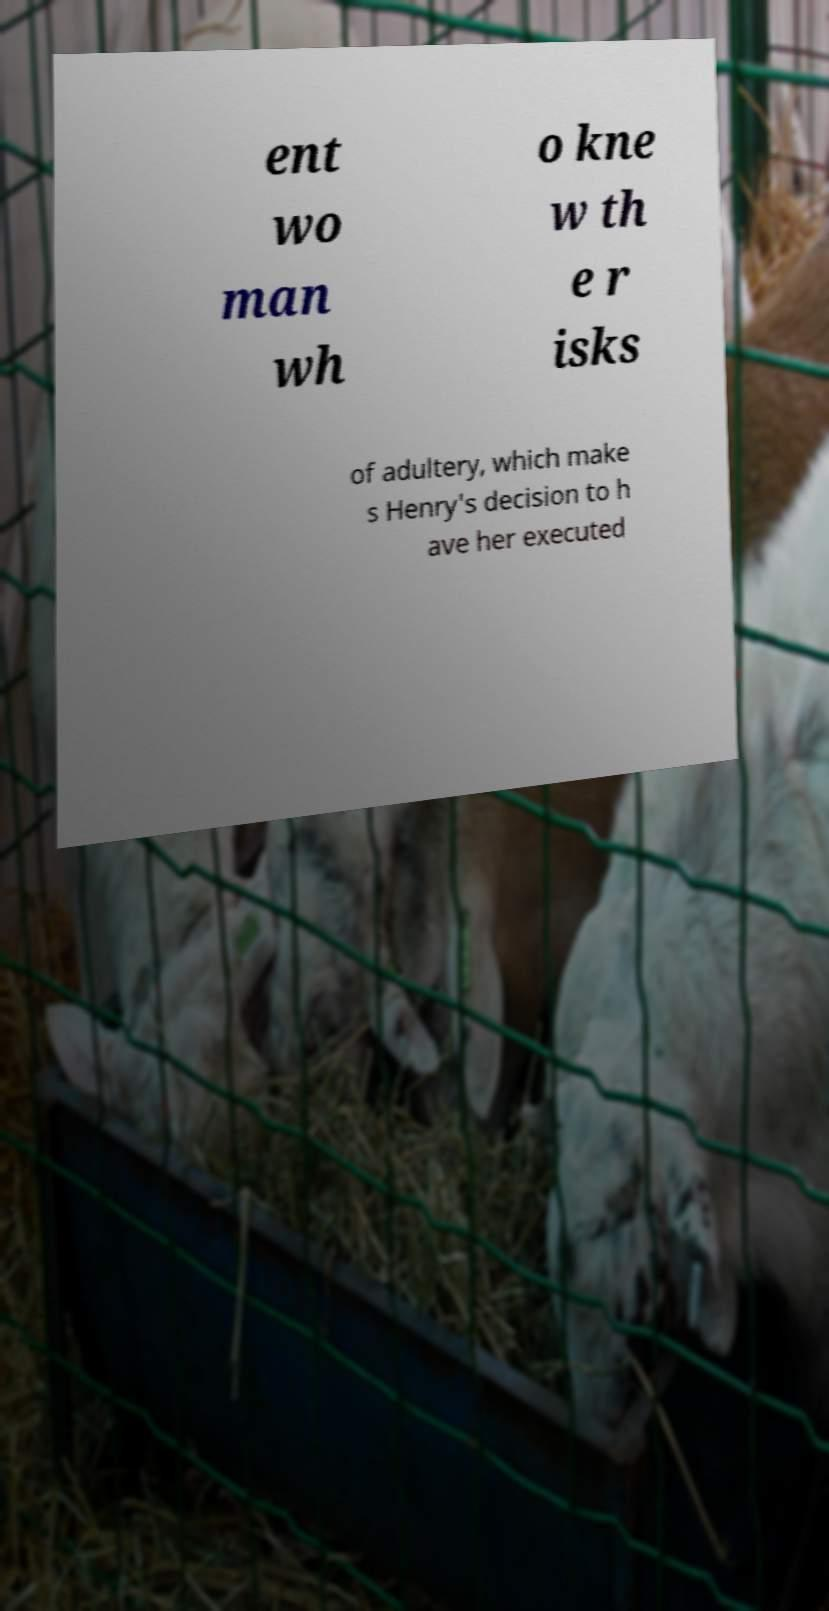Could you extract and type out the text from this image? ent wo man wh o kne w th e r isks of adultery, which make s Henry's decision to h ave her executed 